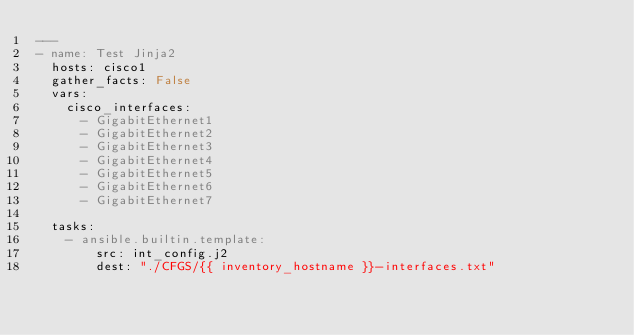<code> <loc_0><loc_0><loc_500><loc_500><_YAML_>---
- name: Test Jinja2
  hosts: cisco1
  gather_facts: False
  vars:
    cisco_interfaces:
      - GigabitEthernet1
      - GigabitEthernet2
      - GigabitEthernet3
      - GigabitEthernet4
      - GigabitEthernet5
      - GigabitEthernet6
      - GigabitEthernet7

  tasks:
    - ansible.builtin.template:
        src: int_config.j2
        dest: "./CFGS/{{ inventory_hostname }}-interfaces.txt"
</code> 